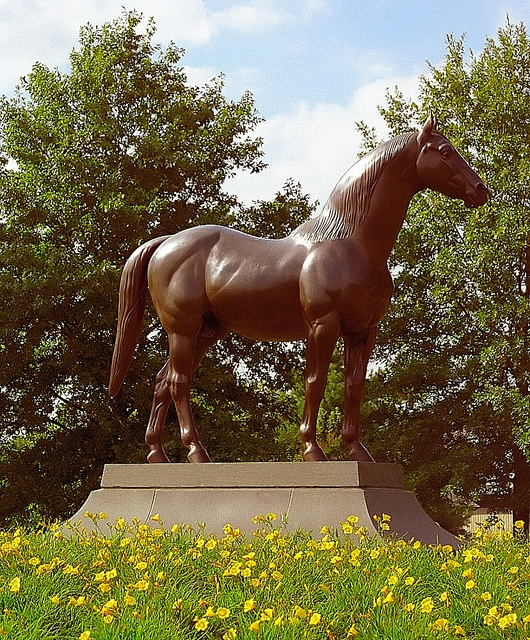Describe the objects in this image and their specific colors. I can see a horse in white, maroon, and gray tones in this image. 